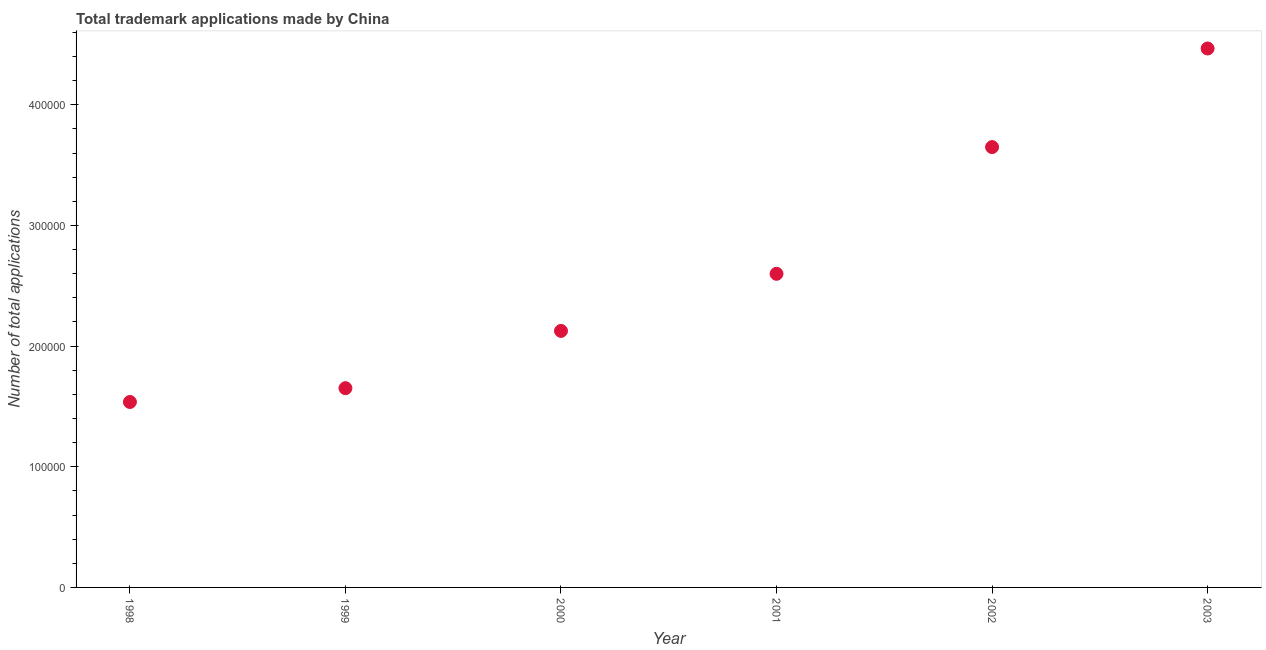What is the number of trademark applications in 1998?
Keep it short and to the point. 1.54e+05. Across all years, what is the maximum number of trademark applications?
Your answer should be very brief. 4.47e+05. Across all years, what is the minimum number of trademark applications?
Offer a very short reply. 1.54e+05. In which year was the number of trademark applications maximum?
Ensure brevity in your answer.  2003. What is the sum of the number of trademark applications?
Provide a succinct answer. 1.60e+06. What is the difference between the number of trademark applications in 1999 and 2000?
Give a very brief answer. -4.75e+04. What is the average number of trademark applications per year?
Offer a terse response. 2.67e+05. What is the median number of trademark applications?
Offer a terse response. 2.36e+05. In how many years, is the number of trademark applications greater than 300000 ?
Provide a succinct answer. 2. What is the ratio of the number of trademark applications in 2000 to that in 2003?
Ensure brevity in your answer.  0.48. What is the difference between the highest and the second highest number of trademark applications?
Your answer should be compact. 8.17e+04. Is the sum of the number of trademark applications in 1998 and 2003 greater than the maximum number of trademark applications across all years?
Ensure brevity in your answer.  Yes. What is the difference between the highest and the lowest number of trademark applications?
Your answer should be compact. 2.93e+05. Does the graph contain any zero values?
Give a very brief answer. No. Does the graph contain grids?
Provide a short and direct response. No. What is the title of the graph?
Keep it short and to the point. Total trademark applications made by China. What is the label or title of the X-axis?
Provide a short and direct response. Year. What is the label or title of the Y-axis?
Keep it short and to the point. Number of total applications. What is the Number of total applications in 1998?
Provide a succinct answer. 1.54e+05. What is the Number of total applications in 1999?
Give a very brief answer. 1.65e+05. What is the Number of total applications in 2000?
Your answer should be compact. 2.13e+05. What is the Number of total applications in 2001?
Your answer should be very brief. 2.60e+05. What is the Number of total applications in 2002?
Provide a succinct answer. 3.65e+05. What is the Number of total applications in 2003?
Offer a very short reply. 4.47e+05. What is the difference between the Number of total applications in 1998 and 1999?
Provide a succinct answer. -1.14e+04. What is the difference between the Number of total applications in 1998 and 2000?
Provide a succinct answer. -5.89e+04. What is the difference between the Number of total applications in 1998 and 2001?
Make the answer very short. -1.06e+05. What is the difference between the Number of total applications in 1998 and 2002?
Provide a succinct answer. -2.11e+05. What is the difference between the Number of total applications in 1998 and 2003?
Provide a short and direct response. -2.93e+05. What is the difference between the Number of total applications in 1999 and 2000?
Your answer should be compact. -4.75e+04. What is the difference between the Number of total applications in 1999 and 2001?
Keep it short and to the point. -9.48e+04. What is the difference between the Number of total applications in 1999 and 2002?
Ensure brevity in your answer.  -2.00e+05. What is the difference between the Number of total applications in 1999 and 2003?
Give a very brief answer. -2.82e+05. What is the difference between the Number of total applications in 2000 and 2001?
Give a very brief answer. -4.73e+04. What is the difference between the Number of total applications in 2000 and 2002?
Offer a terse response. -1.52e+05. What is the difference between the Number of total applications in 2000 and 2003?
Keep it short and to the point. -2.34e+05. What is the difference between the Number of total applications in 2001 and 2002?
Offer a terse response. -1.05e+05. What is the difference between the Number of total applications in 2001 and 2003?
Your response must be concise. -1.87e+05. What is the difference between the Number of total applications in 2002 and 2003?
Keep it short and to the point. -8.17e+04. What is the ratio of the Number of total applications in 1998 to that in 2000?
Keep it short and to the point. 0.72. What is the ratio of the Number of total applications in 1998 to that in 2001?
Make the answer very short. 0.59. What is the ratio of the Number of total applications in 1998 to that in 2002?
Keep it short and to the point. 0.42. What is the ratio of the Number of total applications in 1998 to that in 2003?
Provide a succinct answer. 0.34. What is the ratio of the Number of total applications in 1999 to that in 2000?
Give a very brief answer. 0.78. What is the ratio of the Number of total applications in 1999 to that in 2001?
Provide a succinct answer. 0.64. What is the ratio of the Number of total applications in 1999 to that in 2002?
Make the answer very short. 0.45. What is the ratio of the Number of total applications in 1999 to that in 2003?
Offer a very short reply. 0.37. What is the ratio of the Number of total applications in 2000 to that in 2001?
Ensure brevity in your answer.  0.82. What is the ratio of the Number of total applications in 2000 to that in 2002?
Provide a short and direct response. 0.58. What is the ratio of the Number of total applications in 2000 to that in 2003?
Your response must be concise. 0.48. What is the ratio of the Number of total applications in 2001 to that in 2002?
Ensure brevity in your answer.  0.71. What is the ratio of the Number of total applications in 2001 to that in 2003?
Keep it short and to the point. 0.58. What is the ratio of the Number of total applications in 2002 to that in 2003?
Keep it short and to the point. 0.82. 